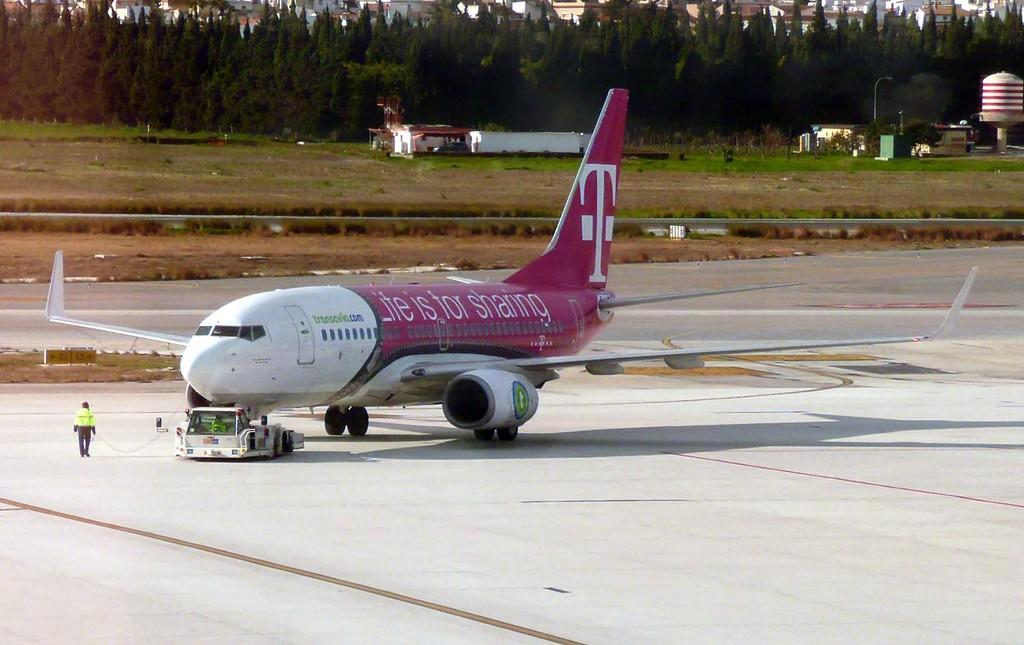<image>
Create a compact narrative representing the image presented. A T-Mobile plane with the slogan "Life is for sharing" on the side. 